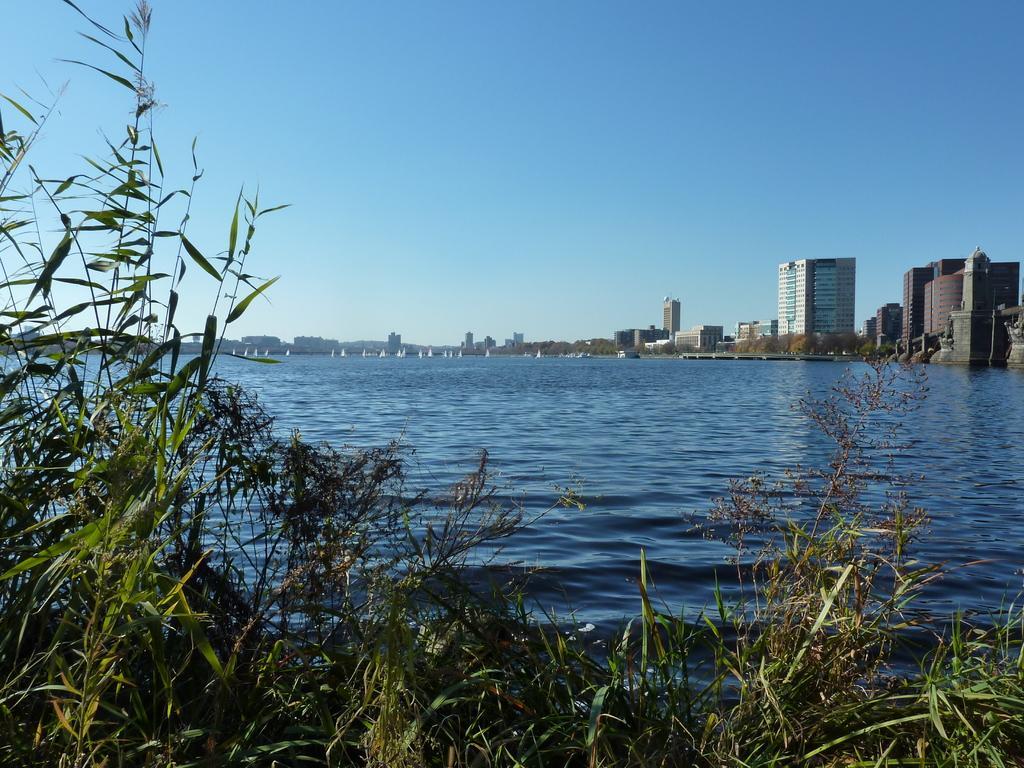Can you describe this image briefly? In this image we can see the water and there are some plants at the bottom of the image. We can see some buildings and trees in the background and at the top we can see the sky. 